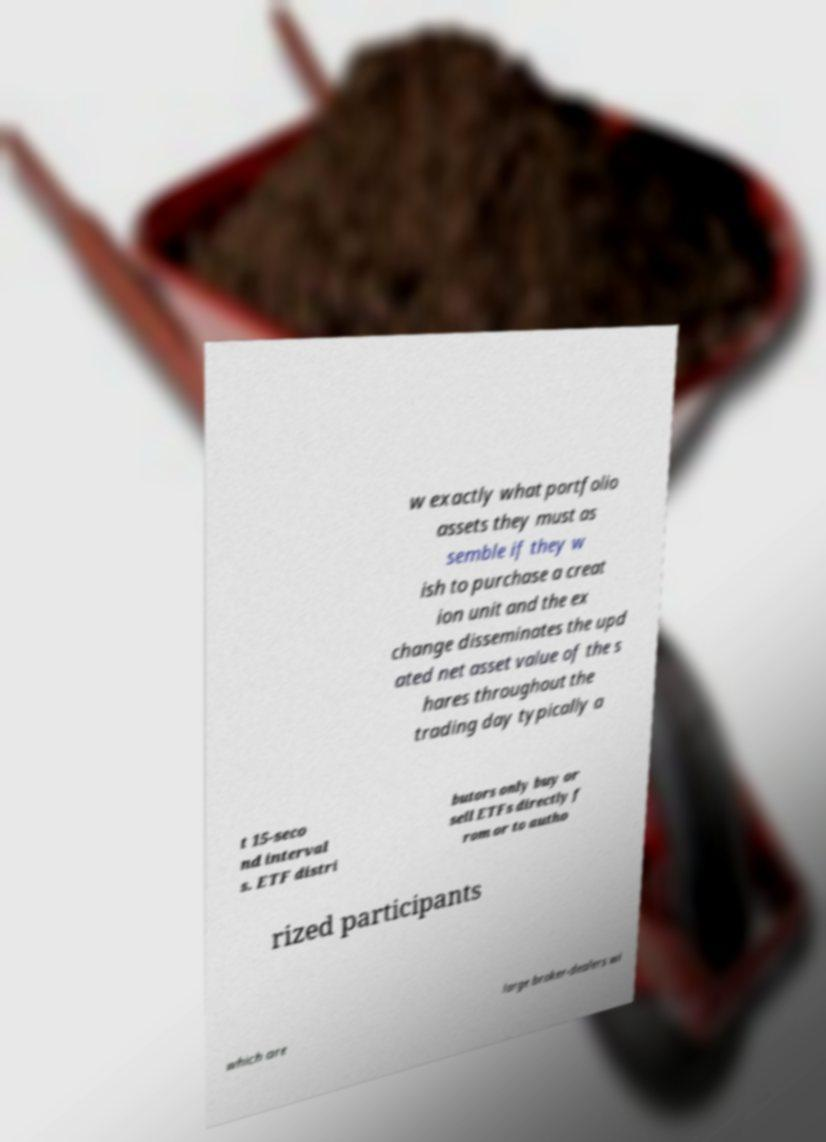Could you extract and type out the text from this image? w exactly what portfolio assets they must as semble if they w ish to purchase a creat ion unit and the ex change disseminates the upd ated net asset value of the s hares throughout the trading day typically a t 15-seco nd interval s. ETF distri butors only buy or sell ETFs directly f rom or to autho rized participants which are large broker-dealers wi 